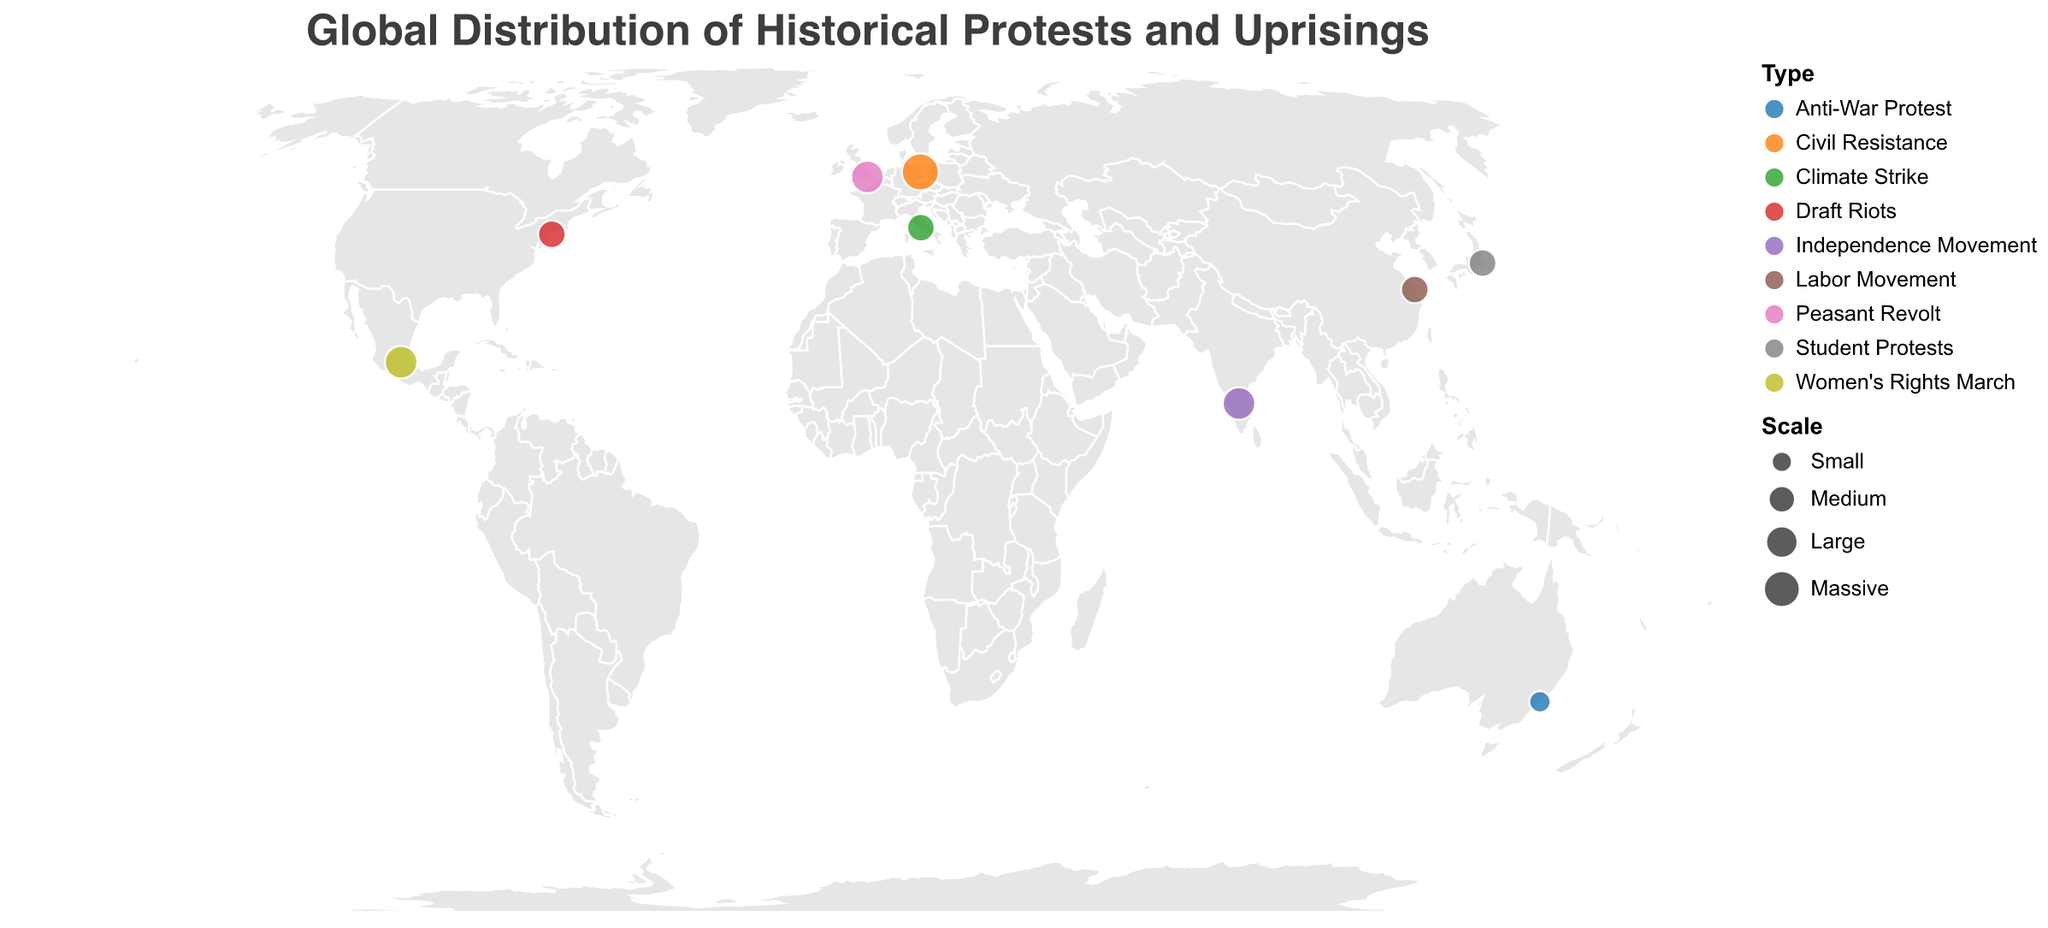What is the title of the geographic plot? The title of the plot is found at the top and is displayed prominently in a larger font.
Answer: Global Distribution of Historical Protests and Uprisings How many protests in the plot are categorized as 'Medium' scale? By examining the plot's legend and identifying 'Medium' scale protests indicated by circle sizes, we can count them.
Answer: 4 Which location had a 'Massive' scale protest, and what was the type of this protest? The location of 'Massive' scale is marked by the largest circle size on the plot. The tooltip provides its type and location.
Answer: Berlin, Civil Resistance Among the depicted protests, which occurred the earliest, and what type was it? By checking the 'Year' attribute in the tooltips for each point, we can find the earliest protest.
Answer: London, Peasant Revolt Compare the scales of protests in London and Mexico City. Which was larger? By referring to the circle sizes for the two locations, the larger circle indicates the larger scale protest.
Answer: Mexico City How many different types of protests are shown on the plot? By looking at the color legend, each type of protest is represented by a different color. We count the distinct colors/types.
Answer: 8 What is common about the protests in Tokyo and New York City in terms of scale? By examining the sizes of the circles for Tokyo and New York City, we observe that they are the same size.
Answer: Both are Medium scale Which protest had the description "First teach-in against Vietnam War in Australia"? By hovering over or checking each tooltip's description, we identify the protest.
Answer: Sydney, 1965 Calculate the average year of the protests shown on the plot. Sum the years of all protests and divide by the number of protests: (1381 + 1863 + 1925 + 1947 + 1965 + 1968 + 1989 + 2019 + 2020) / 9 = 18586 / 9 = 2065.11.
Answer: 2065 Which continents have documented protests in the given data? By observing the geographic distribution of the data points across the continents on the plot.
Answer: Europe, North America, Asia, Australia, and South America 